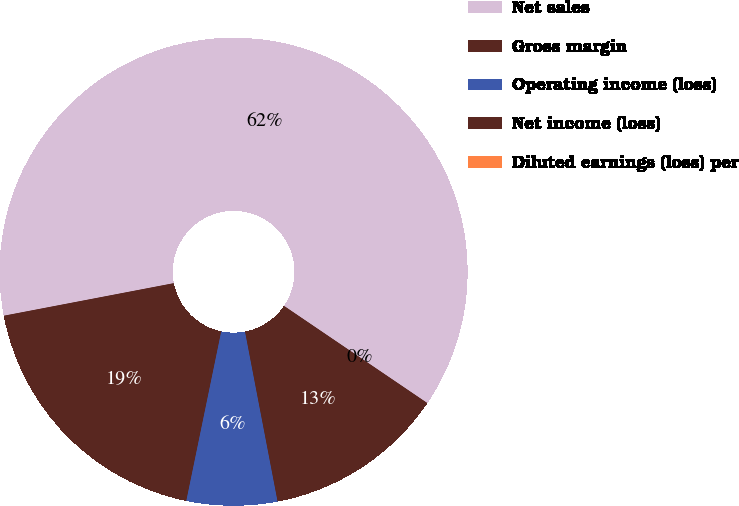Convert chart to OTSL. <chart><loc_0><loc_0><loc_500><loc_500><pie_chart><fcel>Net sales<fcel>Gross margin<fcel>Operating income (loss)<fcel>Net income (loss)<fcel>Diluted earnings (loss) per<nl><fcel>62.49%<fcel>18.75%<fcel>6.25%<fcel>12.5%<fcel>0.0%<nl></chart> 